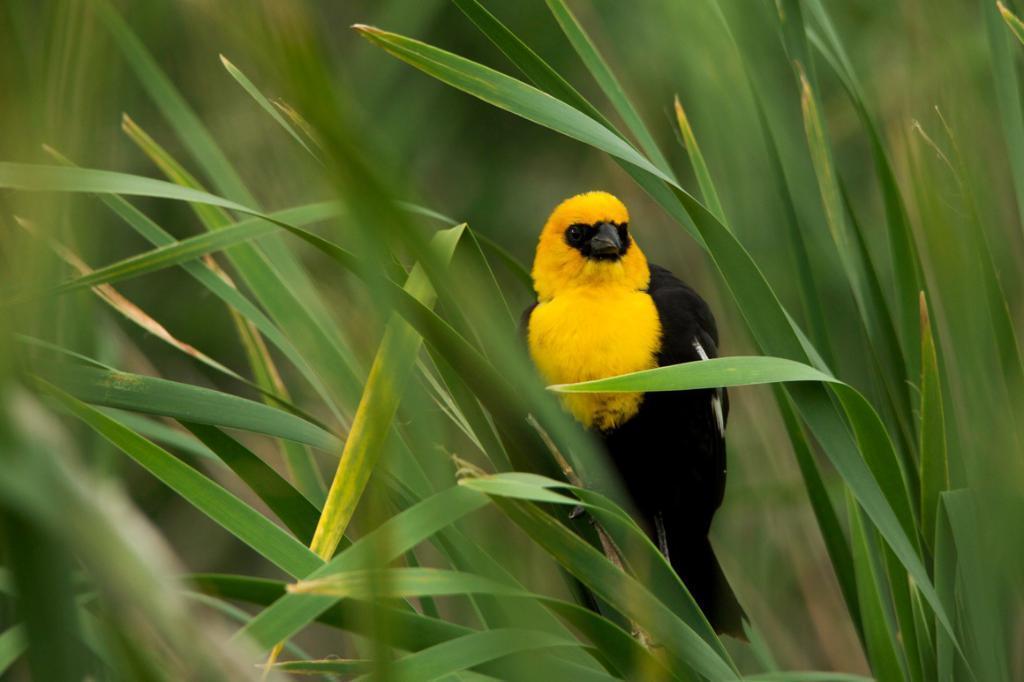In one or two sentences, can you explain what this image depicts? In this image we can see some plants and there is a bird on the plant and in the background the image is blurred. 